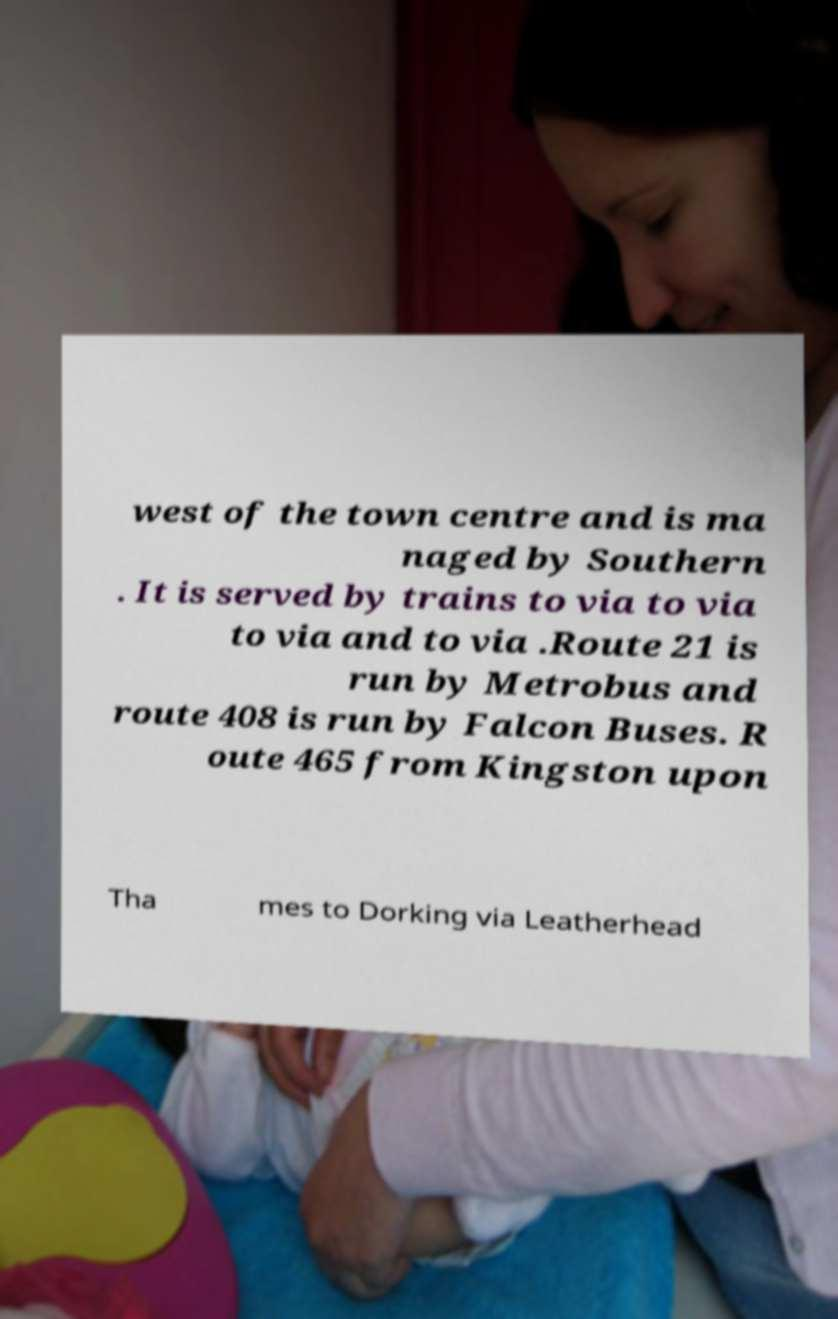Please read and relay the text visible in this image. What does it say? west of the town centre and is ma naged by Southern . It is served by trains to via to via to via and to via .Route 21 is run by Metrobus and route 408 is run by Falcon Buses. R oute 465 from Kingston upon Tha mes to Dorking via Leatherhead 